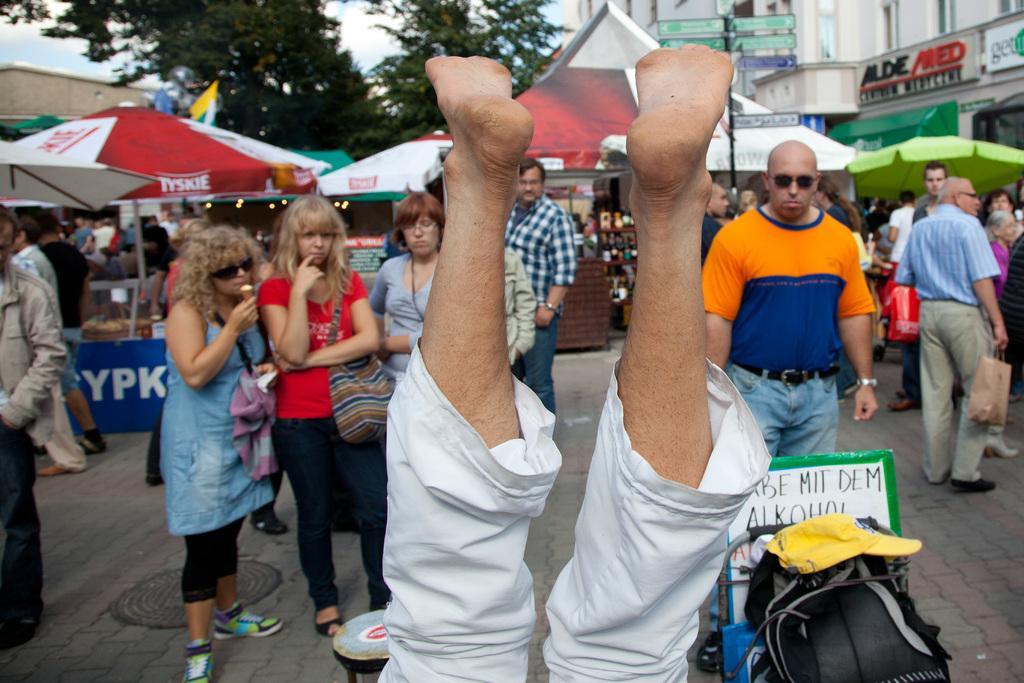In one or two sentences, can you explain what this image depicts? In the middle of the image we can see two legs. Behind the legs few people are standing and walking. Behind them there are some tents and trees and buildings and poles and sign boards. 